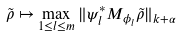Convert formula to latex. <formula><loc_0><loc_0><loc_500><loc_500>\tilde { \rho } \mapsto \max _ { 1 \leq l \leq m } \| \psi _ { l } ^ { \ast } M _ { \phi _ { l } } \tilde { \rho } \| _ { k + \alpha }</formula> 